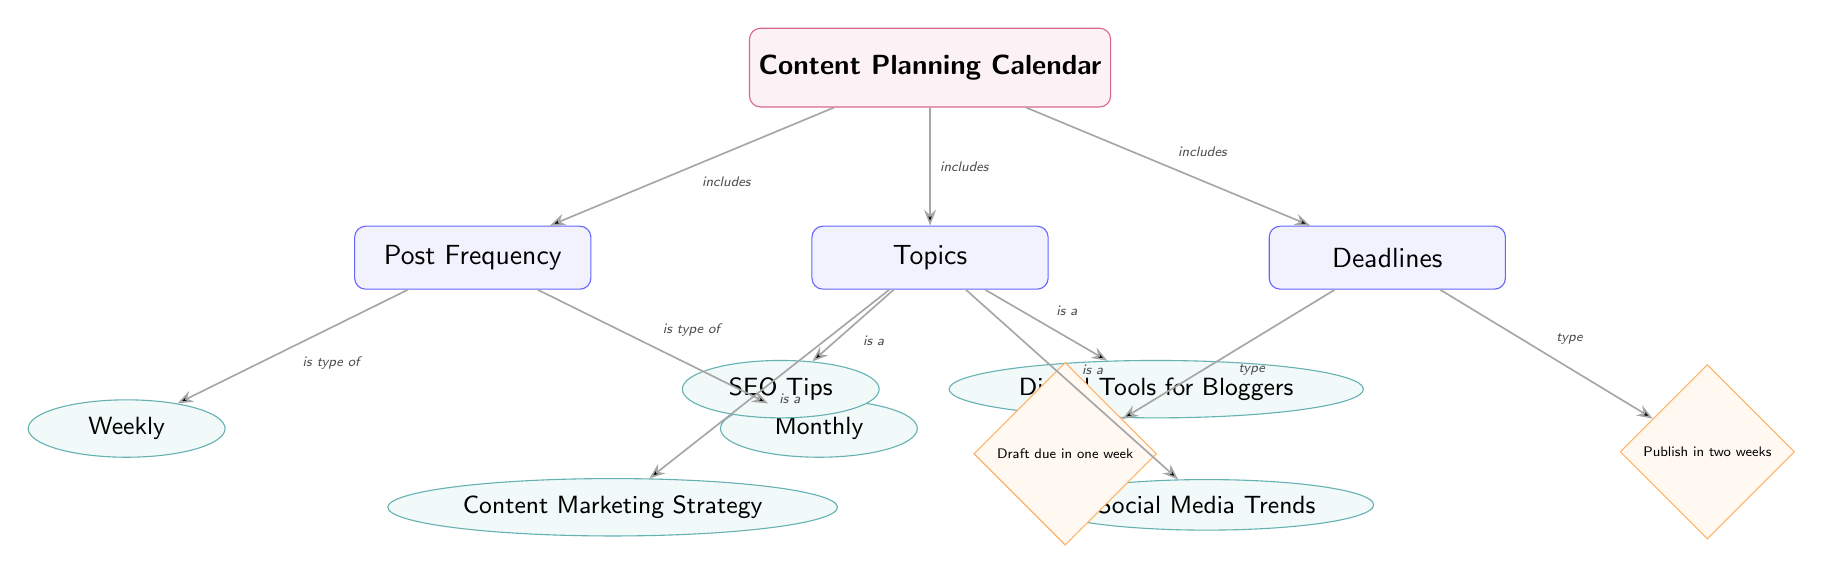What are the two types of post frequency? The diagram clearly shows two subcategory nodes under the 'Post Frequency' category, labeled 'Weekly' and 'Monthly'. This indicates that the post frequency can be classified into these two types.
Answer: Weekly, Monthly How many topics are identified in the diagram? In the 'Topics' category, there are four subcategory nodes listed: 'SEO Tips', 'Content Marketing Strategy', 'Digital Tools for Bloggers', and 'Social Media Trends'. Counting these gives a total of four topics.
Answer: 4 What is the deadline for the draft? The left subcategory node under the 'Deadlines' category is labeled 'Draft due in one week', which indicates the specific deadline for drafts.
Answer: Draft due in one week What is the relationship between the 'Content Planning Calendar' and 'Post Frequency'? The edge between the 'Content Planning Calendar' node and the 'Post Frequency' node is labeled "includes", indicating that post frequency is a part of the overall content planning calendar.
Answer: includes Which topic is associated with digital tools? The 'Digital Tools for Bloggers' node is placed under the 'Topics' category in the diagram, making it clear that this specific topic addresses digital tools relevant to bloggers.
Answer: Digital Tools for Bloggers How many types of deadlines are listed? The 'Deadlines' category contains two subcategory nodes: 'Draft due in one week' and 'Publish in two weeks'. Thus, there are two types of deadlines specified in the diagram.
Answer: 2 What type of node is 'Publish in two weeks'? The node 'Publish in two weeks' is shaped as a diamond and is part of the 'Deadlines' category, which signifies that it is categorized as a deadline type node in the diagram.
Answer: deadline Is 'SEO Tips' a subcategory or a main category? The node 'SEO Tips' is positioned as an ellipse under the 'Topics' category, indicating that it is a subcategory rather than a main category.
Answer: subcategory 